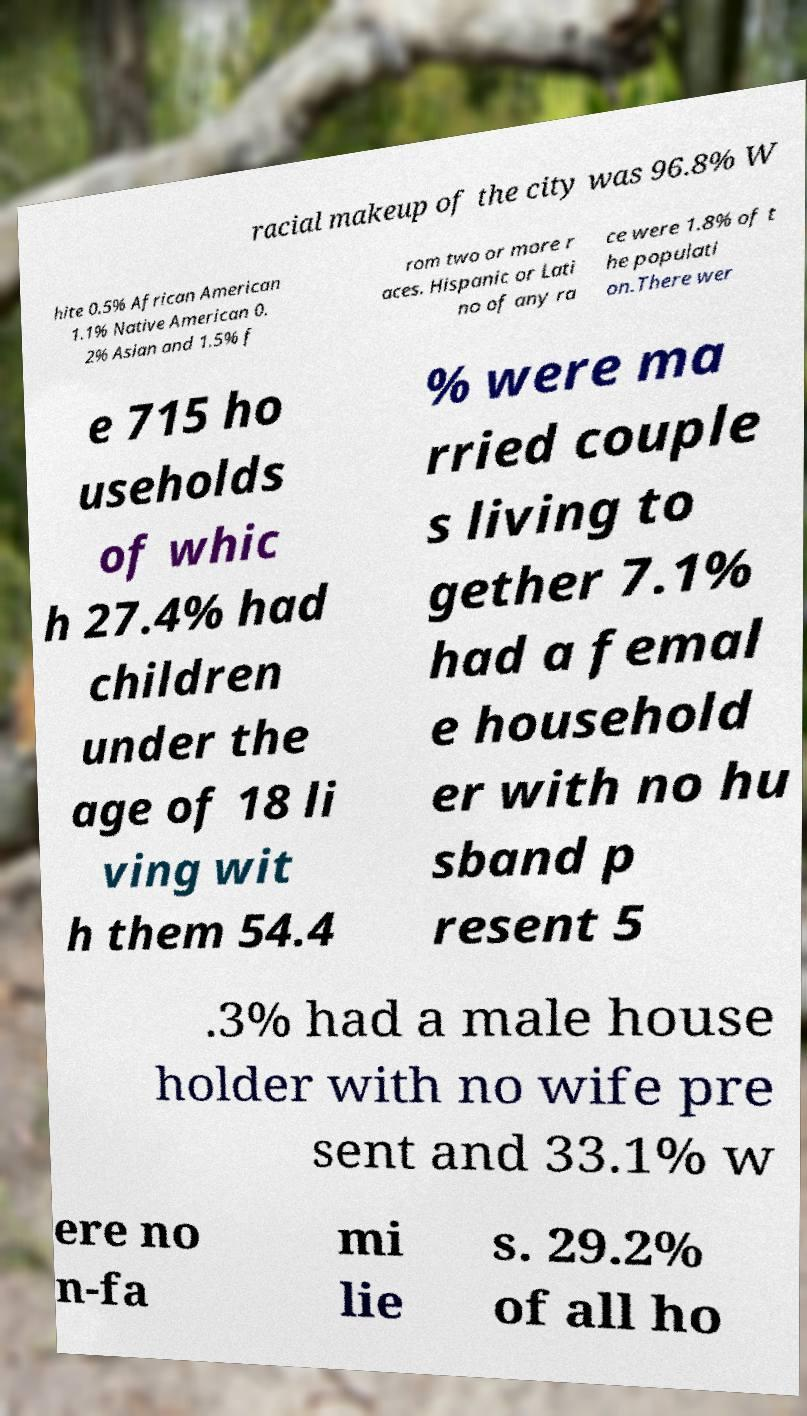Can you read and provide the text displayed in the image?This photo seems to have some interesting text. Can you extract and type it out for me? racial makeup of the city was 96.8% W hite 0.5% African American 1.1% Native American 0. 2% Asian and 1.5% f rom two or more r aces. Hispanic or Lati no of any ra ce were 1.8% of t he populati on.There wer e 715 ho useholds of whic h 27.4% had children under the age of 18 li ving wit h them 54.4 % were ma rried couple s living to gether 7.1% had a femal e household er with no hu sband p resent 5 .3% had a male house holder with no wife pre sent and 33.1% w ere no n-fa mi lie s. 29.2% of all ho 